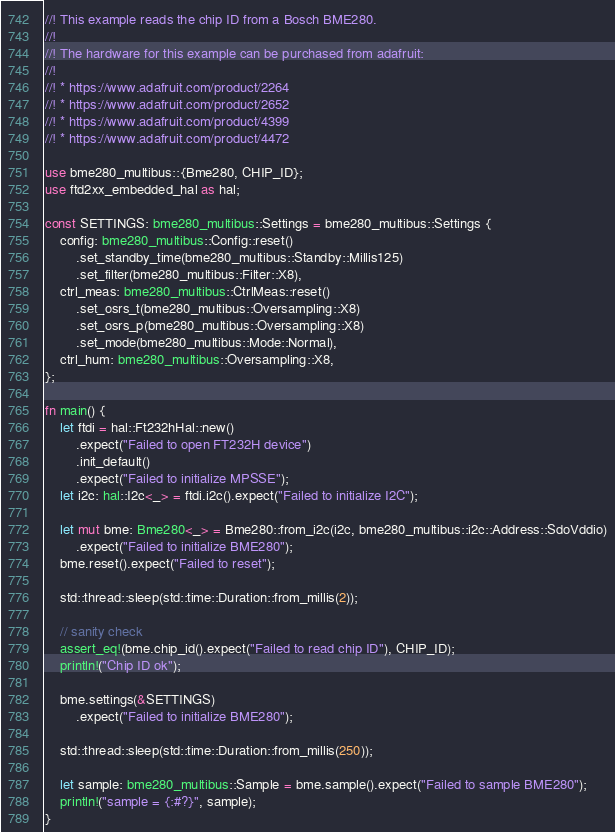Convert code to text. <code><loc_0><loc_0><loc_500><loc_500><_Rust_>//! This example reads the chip ID from a Bosch BME280.
//!
//! The hardware for this example can be purchased from adafruit:
//!
//! * https://www.adafruit.com/product/2264
//! * https://www.adafruit.com/product/2652
//! * https://www.adafruit.com/product/4399
//! * https://www.adafruit.com/product/4472

use bme280_multibus::{Bme280, CHIP_ID};
use ftd2xx_embedded_hal as hal;

const SETTINGS: bme280_multibus::Settings = bme280_multibus::Settings {
    config: bme280_multibus::Config::reset()
        .set_standby_time(bme280_multibus::Standby::Millis125)
        .set_filter(bme280_multibus::Filter::X8),
    ctrl_meas: bme280_multibus::CtrlMeas::reset()
        .set_osrs_t(bme280_multibus::Oversampling::X8)
        .set_osrs_p(bme280_multibus::Oversampling::X8)
        .set_mode(bme280_multibus::Mode::Normal),
    ctrl_hum: bme280_multibus::Oversampling::X8,
};

fn main() {
    let ftdi = hal::Ft232hHal::new()
        .expect("Failed to open FT232H device")
        .init_default()
        .expect("Failed to initialize MPSSE");
    let i2c: hal::I2c<_> = ftdi.i2c().expect("Failed to initialize I2C");

    let mut bme: Bme280<_> = Bme280::from_i2c(i2c, bme280_multibus::i2c::Address::SdoVddio)
        .expect("Failed to initialize BME280");
    bme.reset().expect("Failed to reset");

    std::thread::sleep(std::time::Duration::from_millis(2));

    // sanity check
    assert_eq!(bme.chip_id().expect("Failed to read chip ID"), CHIP_ID);
    println!("Chip ID ok");

    bme.settings(&SETTINGS)
        .expect("Failed to initialize BME280");

    std::thread::sleep(std::time::Duration::from_millis(250));

    let sample: bme280_multibus::Sample = bme.sample().expect("Failed to sample BME280");
    println!("sample = {:#?}", sample);
}
</code> 